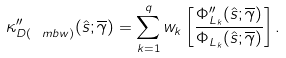<formula> <loc_0><loc_0><loc_500><loc_500>\kappa _ { D ( \ m b { w } ) } ^ { \prime \prime } ( \hat { s } ; \overline { \gamma } ) & = \sum _ { k = 1 } ^ { q } w _ { k } \left [ \frac { \Phi _ { L _ { k } } ^ { \prime \prime } ( \hat { s } ; \overline { \gamma } ) } { \Phi _ { L _ { k } } ( \hat { s } ; \overline { \gamma } ) } \right ] .</formula> 